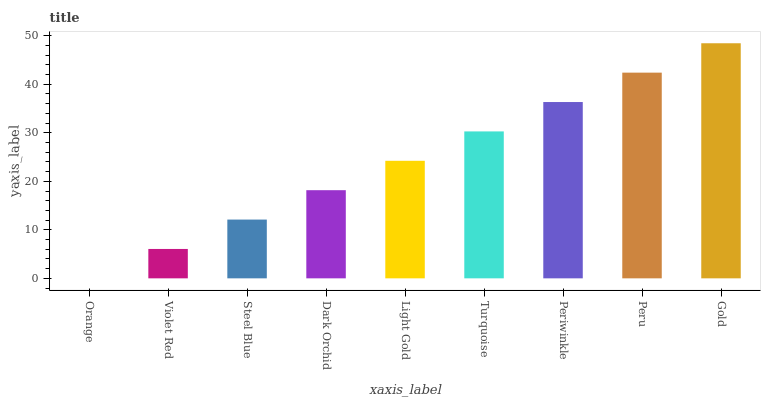Is Orange the minimum?
Answer yes or no. Yes. Is Gold the maximum?
Answer yes or no. Yes. Is Violet Red the minimum?
Answer yes or no. No. Is Violet Red the maximum?
Answer yes or no. No. Is Violet Red greater than Orange?
Answer yes or no. Yes. Is Orange less than Violet Red?
Answer yes or no. Yes. Is Orange greater than Violet Red?
Answer yes or no. No. Is Violet Red less than Orange?
Answer yes or no. No. Is Light Gold the high median?
Answer yes or no. Yes. Is Light Gold the low median?
Answer yes or no. Yes. Is Turquoise the high median?
Answer yes or no. No. Is Orange the low median?
Answer yes or no. No. 